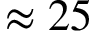<formula> <loc_0><loc_0><loc_500><loc_500>\approx 2 5</formula> 